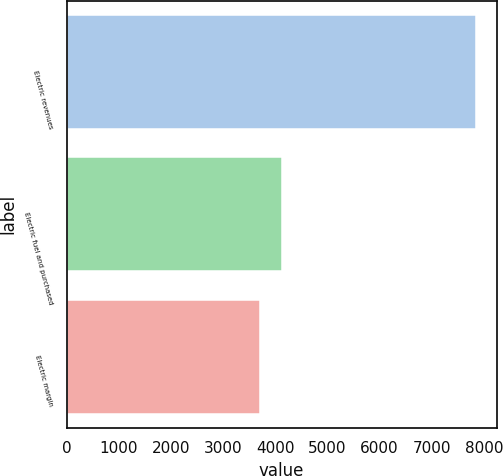<chart> <loc_0><loc_0><loc_500><loc_500><bar_chart><fcel>Electric revenues<fcel>Electric fuel and purchased<fcel>Electric margin<nl><fcel>7848<fcel>4137<fcel>3711<nl></chart> 